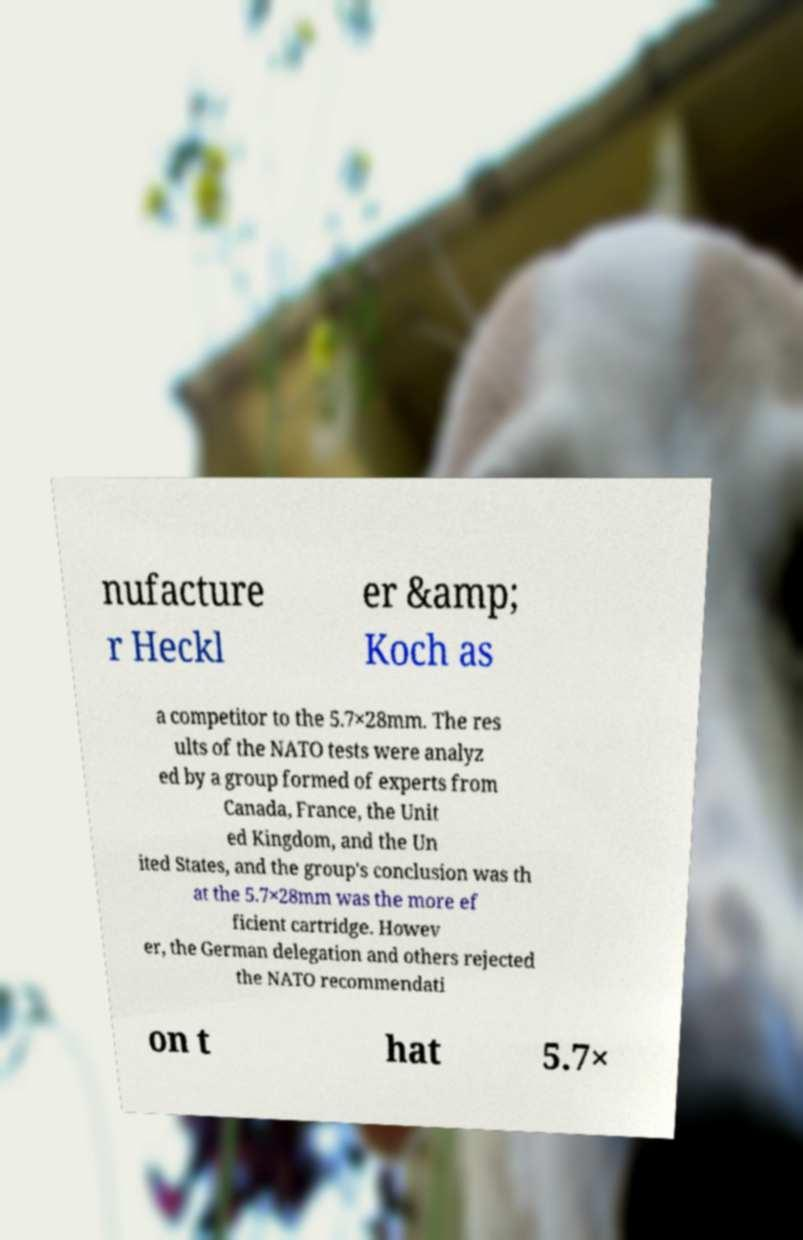Please read and relay the text visible in this image. What does it say? nufacture r Heckl er &amp; Koch as a competitor to the 5.7×28mm. The res ults of the NATO tests were analyz ed by a group formed of experts from Canada, France, the Unit ed Kingdom, and the Un ited States, and the group's conclusion was th at the 5.7×28mm was the more ef ficient cartridge. Howev er, the German delegation and others rejected the NATO recommendati on t hat 5.7× 